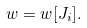Convert formula to latex. <formula><loc_0><loc_0><loc_500><loc_500>w = w [ J _ { i } ] .</formula> 